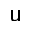Convert formula to latex. <formula><loc_0><loc_0><loc_500><loc_500>u</formula> 